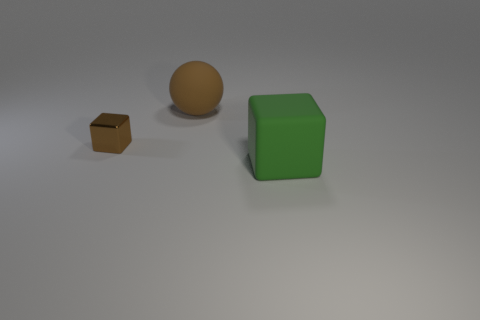Add 3 tiny cyan metal cubes. How many objects exist? 6 Subtract 1 blocks. How many blocks are left? 1 Subtract all green cubes. How many cubes are left? 1 Subtract all blocks. How many objects are left? 1 Subtract all brown balls. How many brown blocks are left? 1 Add 2 big green matte objects. How many big green matte objects exist? 3 Subtract 1 brown spheres. How many objects are left? 2 Subtract all purple balls. Subtract all blue cylinders. How many balls are left? 1 Subtract all metal cubes. Subtract all rubber things. How many objects are left? 0 Add 2 small metal objects. How many small metal objects are left? 3 